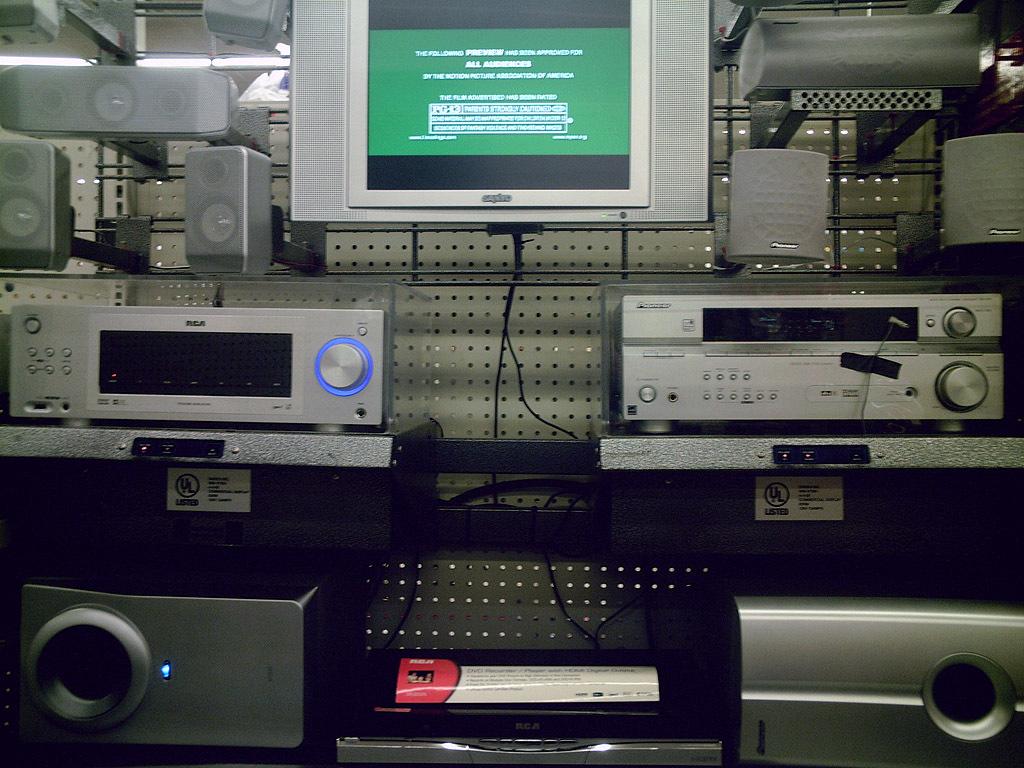What brand is the left-middle electronic?
Give a very brief answer. Rca. 